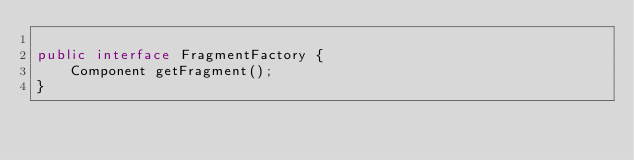<code> <loc_0><loc_0><loc_500><loc_500><_Java_>
public interface FragmentFactory {
    Component getFragment();
}
</code> 